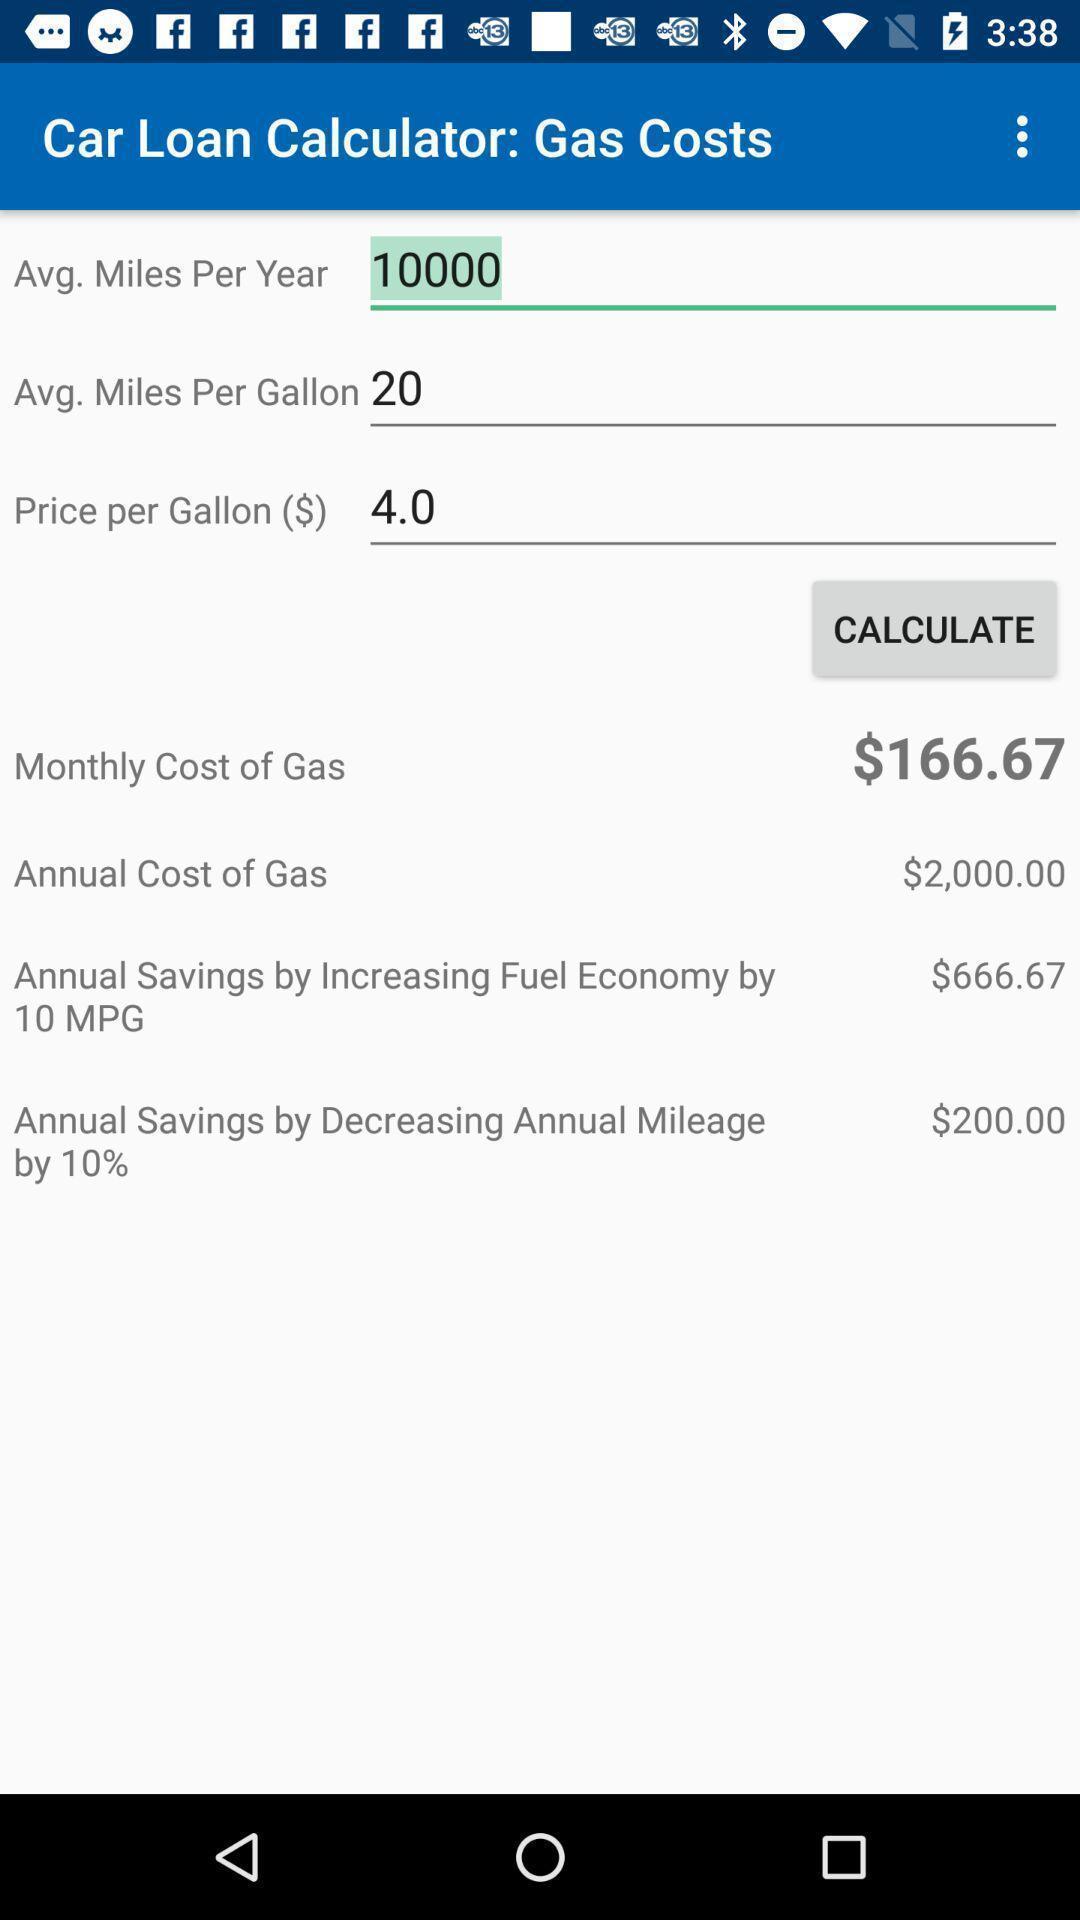Describe the content in this image. Social app for calculating your loan. 